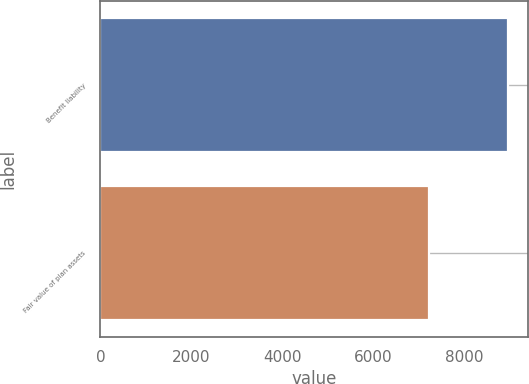Convert chart to OTSL. <chart><loc_0><loc_0><loc_500><loc_500><bar_chart><fcel>Benefit liability<fcel>Fair value of plan assets<nl><fcel>8957<fcel>7223<nl></chart> 